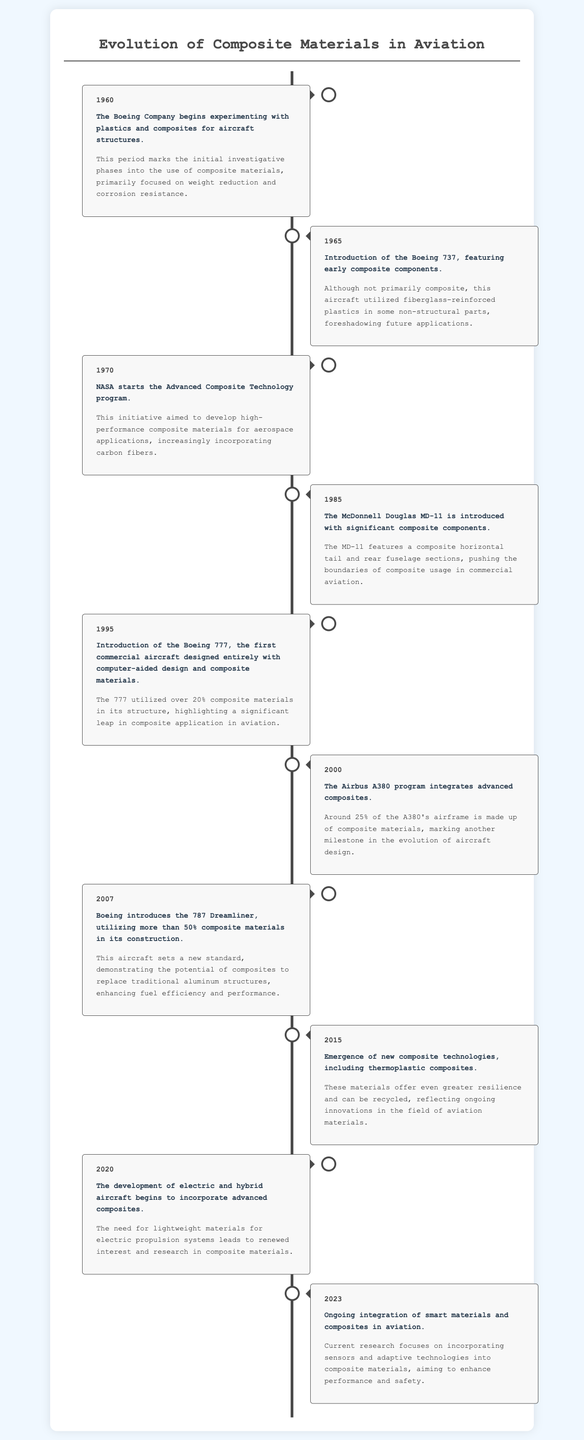What year did Boeing begin experimenting with plastics and composites? The document states that Boeing began experimenting with plastics and composites in 1960.
Answer: 1960 What significant composite components were introduced with the McDonnell Douglas MD-11? The MD-11 featured a composite horizontal tail and rear fuselage sections.
Answer: Composite horizontal tail and rear fuselage sections What percentage of composite materials did the Boeing 777 utilize? The Boeing 777 utilized over 20% composite materials in its structure.
Answer: Over 20% In which year was the Airbus A380 program initiated? The document mentions the introduction of Airbus A380 in 2000, which was when advanced composites were integrated.
Answer: 2000 What advancements in composite technologies emerged in 2015? In 2015, new composite technologies, including thermoplastic composites, emerged.
Answer: Thermoplastic composites What is the main focus of current research in aviation composites as of 2023? The ongoing research in 2023 focuses on incorporating sensors and adaptive technologies into composite materials.
Answer: Incorporating sensors and adaptive technologies Which aircraft was the first designed entirely with computer-aided design and composite materials? The document indicates that the Boeing 777 was the first commercial aircraft designed entirely with computer-aided design and composite materials.
Answer: Boeing 777 How much percentage of composite materials were utilized in the construction of the Boeing 787 Dreamliner? The Boeing 787 Dreamliner utilized more than 50% composite materials in its construction.
Answer: More than 50% 